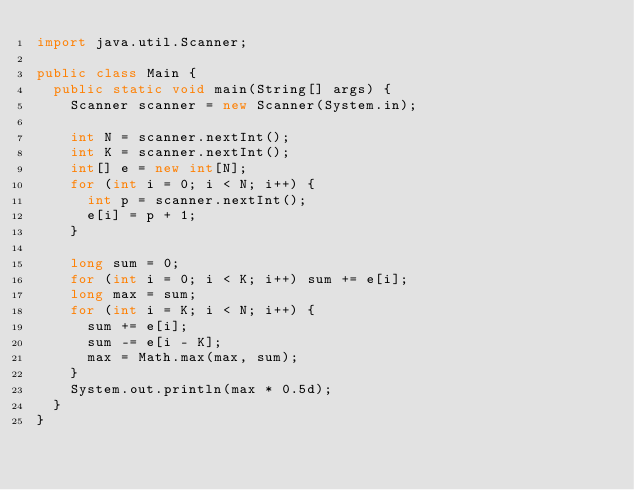Convert code to text. <code><loc_0><loc_0><loc_500><loc_500><_Java_>import java.util.Scanner;

public class Main {
  public static void main(String[] args) {
    Scanner scanner = new Scanner(System.in);

    int N = scanner.nextInt();
    int K = scanner.nextInt();
    int[] e = new int[N];
    for (int i = 0; i < N; i++) {
      int p = scanner.nextInt();
      e[i] = p + 1;
    }

    long sum = 0;
    for (int i = 0; i < K; i++) sum += e[i];
    long max = sum;
    for (int i = K; i < N; i++) {
      sum += e[i];
      sum -= e[i - K];
      max = Math.max(max, sum);
    }
    System.out.println(max * 0.5d);
  }
}
</code> 